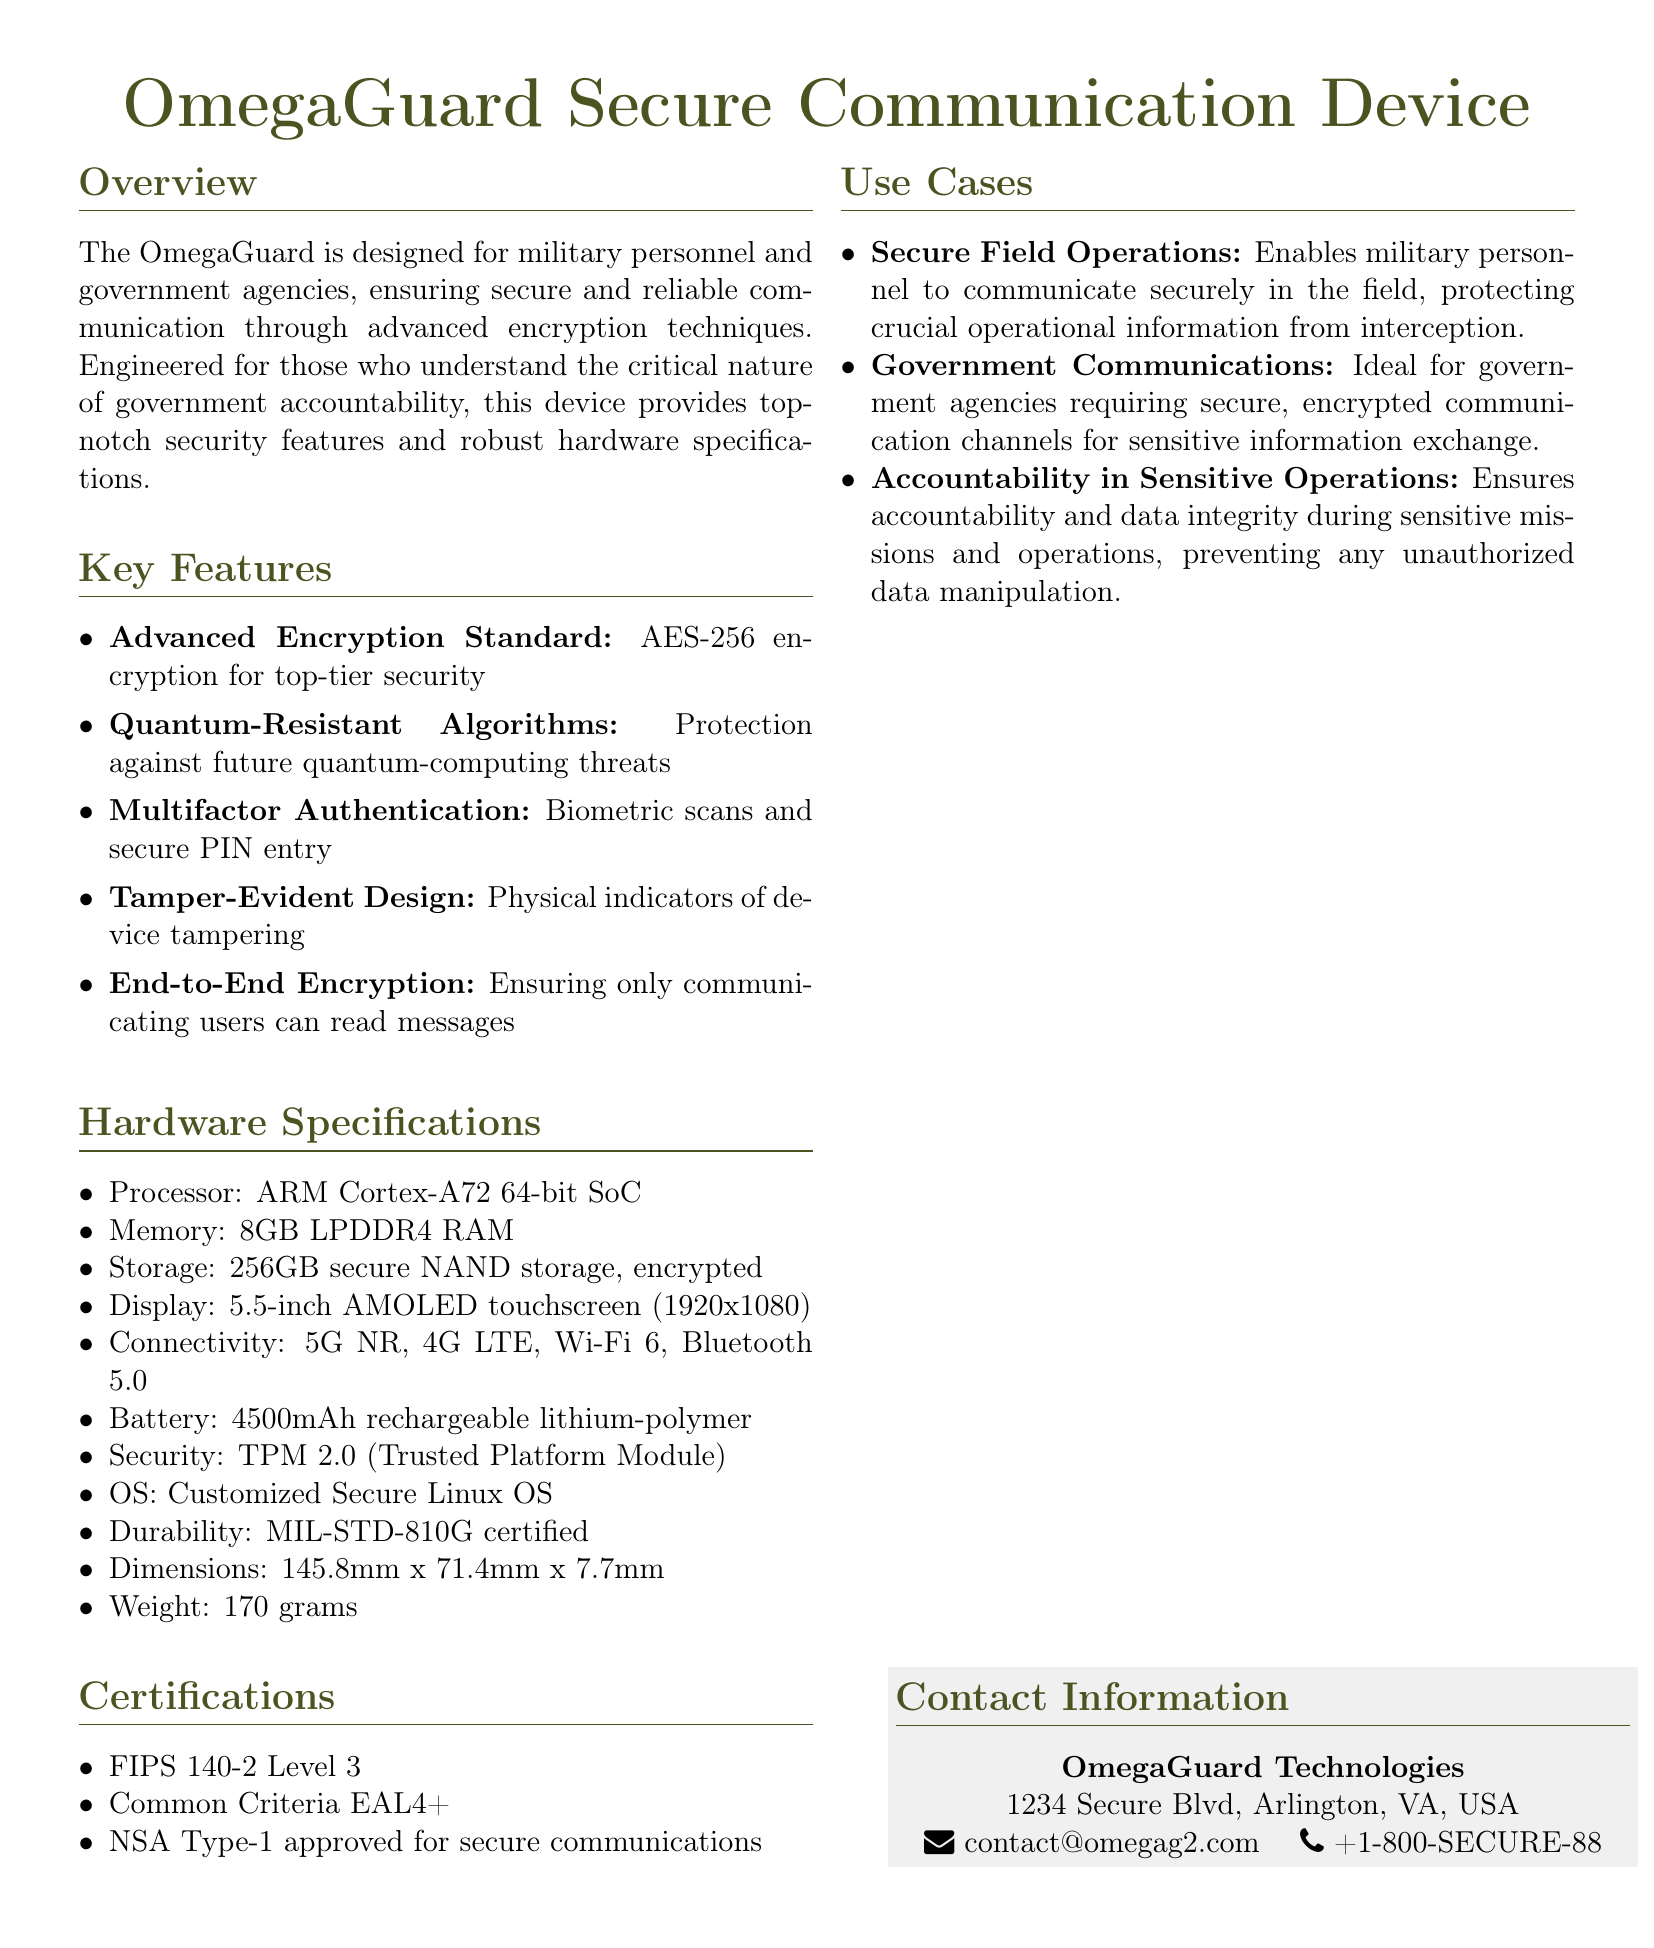What type of encryption does the device use? The document specifies that the device uses AES-256 encryption for security.
Answer: AES-256 What is the battery capacity of the OmegaGuard? The battery capacity is listed as 4500mAh in the hardware specifications.
Answer: 4500mAh How much storage does the OmegaGuard provide? The document states that the device has 256GB secure NAND storage.
Answer: 256GB What certification level does the device hold for FIPS? The document mentions FIPS 140-2 Level 3 certification.
Answer: Level 3 What is the weight of the OmegaGuard? The weight is given as 170 grams in the specifications section.
Answer: 170 grams Which Operating System does the OmegaGuard use? The OS used in the device is a Customized Secure Linux OS according to the specifications.
Answer: Customized Secure Linux OS What is the purpose of the Tamper-Evident Design feature? The Tamper-Evident Design indicates physical indicators of device tampering, ensuring secure communication.
Answer: Physical indicators of device tampering Who is the target user of the OmegaGuard device? The device is designed for military personnel and government agencies requiring secure communication.
Answer: Military personnel and government agencies Which specific use case emphasizes accountability in operations? The use case focusing on accountability is "Accountability in Sensitive Operations."
Answer: Accountability in Sensitive Operations 